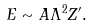Convert formula to latex. <formula><loc_0><loc_0><loc_500><loc_500>E \sim A \Lambda ^ { 2 } Z ^ { \prime } .</formula> 